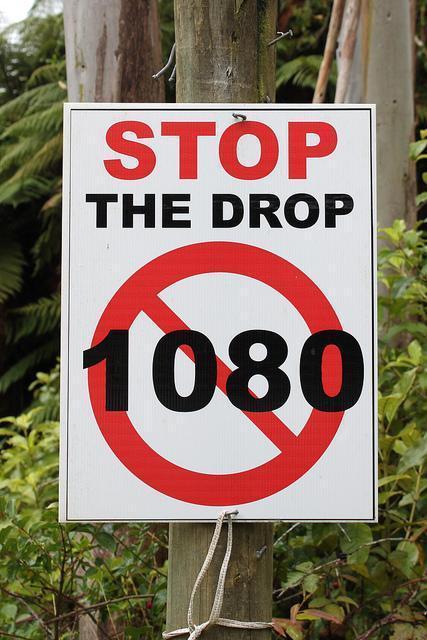How many people are off of the ground?
Give a very brief answer. 0. 